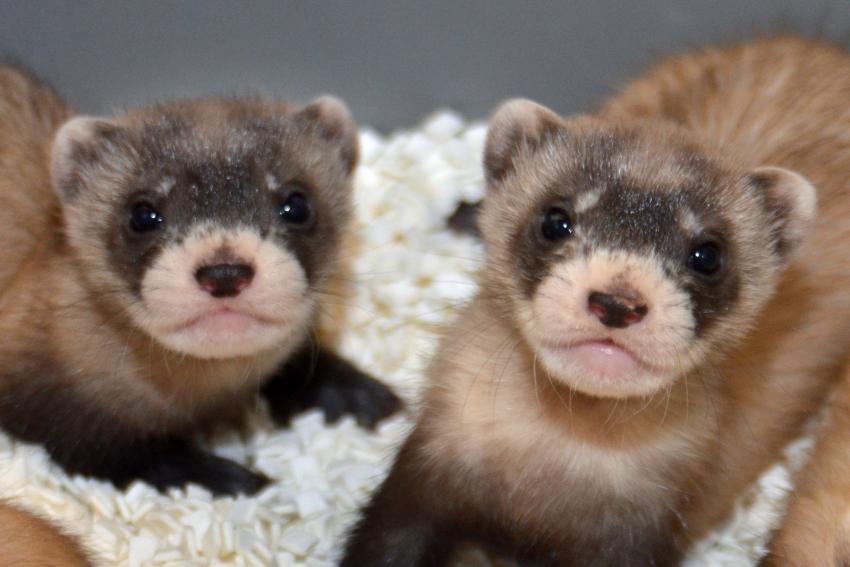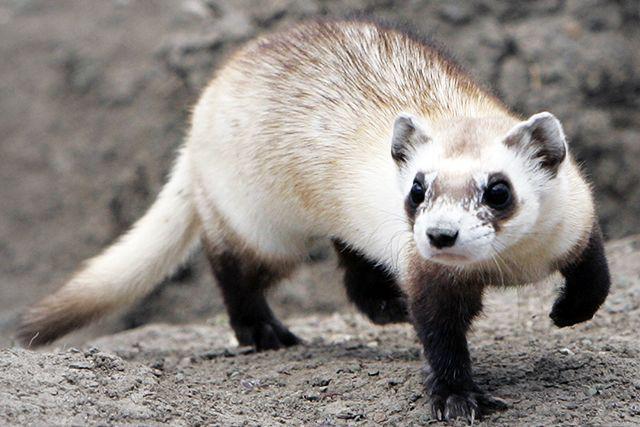The first image is the image on the left, the second image is the image on the right. For the images displayed, is the sentence "There are exactly two ferrets outdoors." factually correct? Answer yes or no. No. The first image is the image on the left, the second image is the image on the right. Considering the images on both sides, is "Every image in the set contains a single ferret, in an outdoor setting." valid? Answer yes or no. No. 